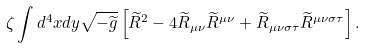<formula> <loc_0><loc_0><loc_500><loc_500>\zeta \int d ^ { 4 } x d y \sqrt { - { \widetilde { g } } } \left [ { \widetilde { R } } ^ { 2 } - 4 { \widetilde { R } } _ { \mu \nu } { \widetilde { R } } ^ { \mu \nu } + { \widetilde { R } } _ { \mu \nu \sigma \tau } { \widetilde { R } } ^ { \mu \nu \sigma \tau } \right ] .</formula> 